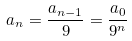Convert formula to latex. <formula><loc_0><loc_0><loc_500><loc_500>a _ { n } = \frac { a _ { n - 1 } } { 9 } = \frac { a _ { 0 } } { 9 ^ { n } }</formula> 